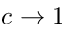<formula> <loc_0><loc_0><loc_500><loc_500>c \rightarrow 1</formula> 